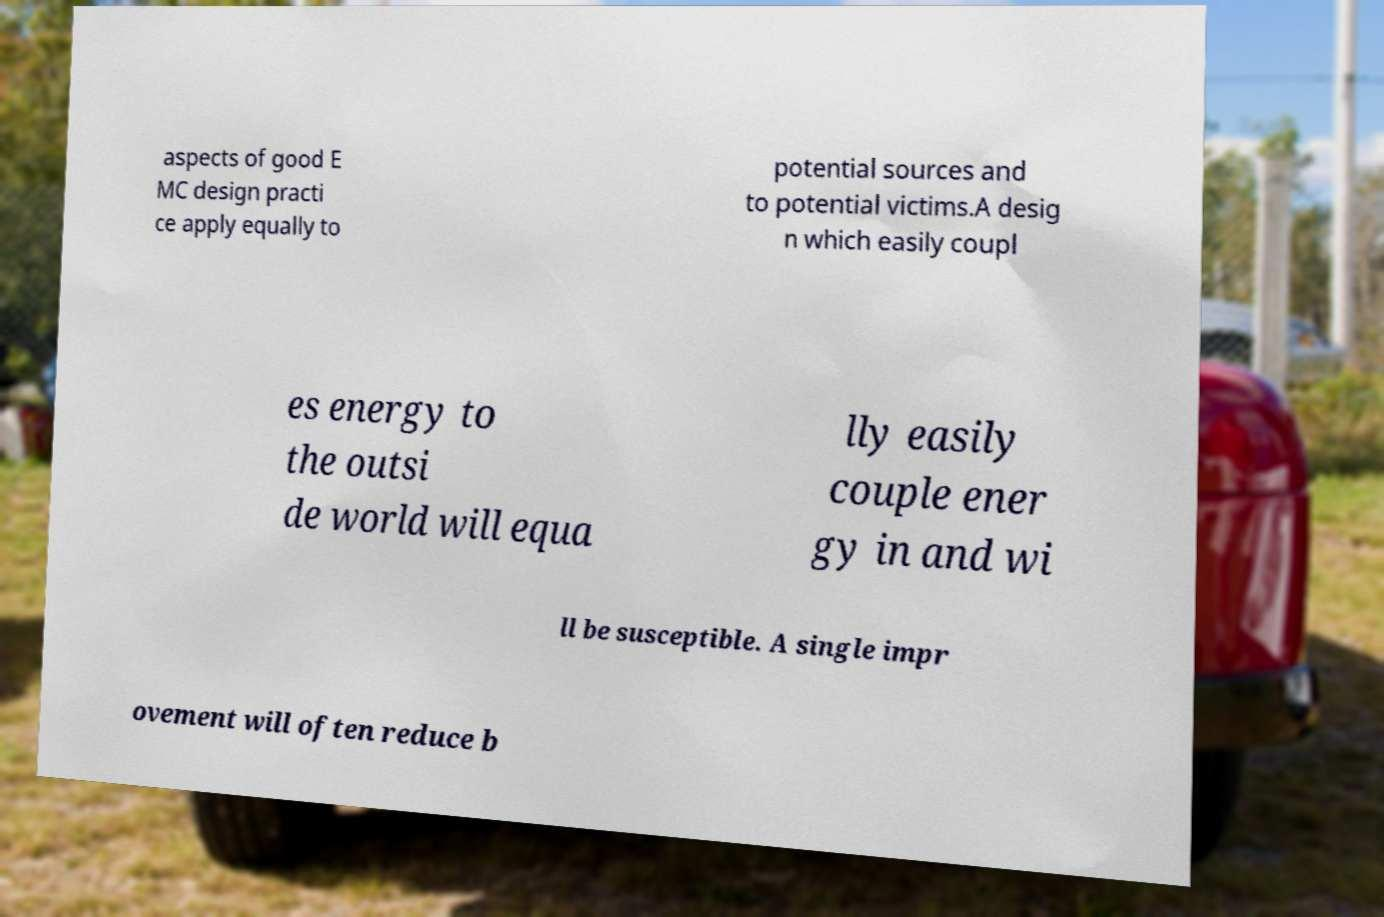Could you assist in decoding the text presented in this image and type it out clearly? aspects of good E MC design practi ce apply equally to potential sources and to potential victims.A desig n which easily coupl es energy to the outsi de world will equa lly easily couple ener gy in and wi ll be susceptible. A single impr ovement will often reduce b 